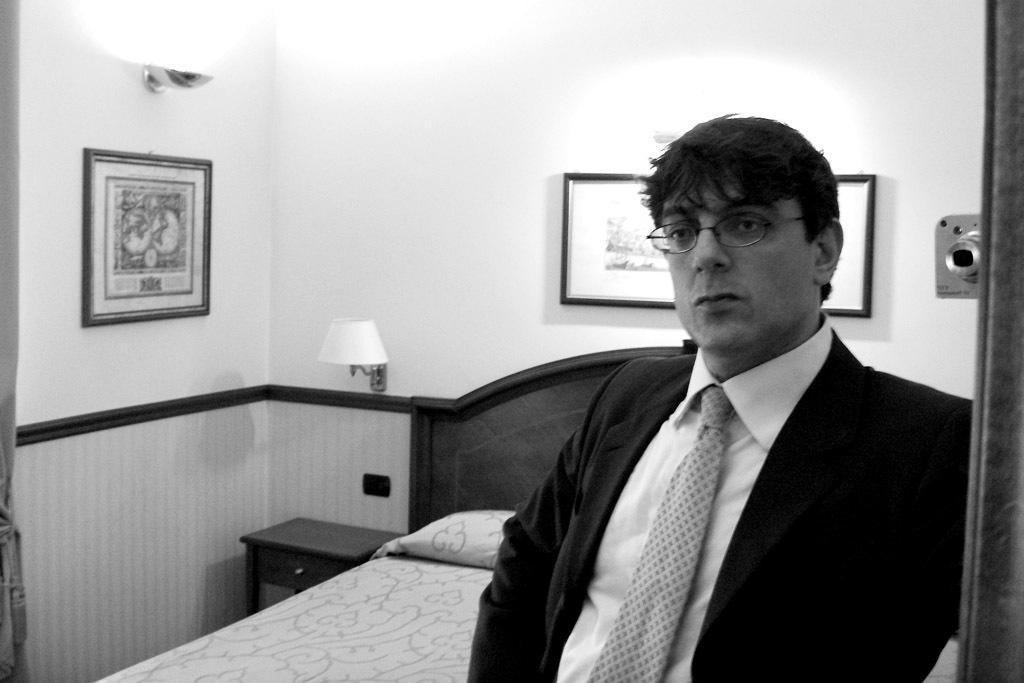What is the person in the image doing? The person is standing. What is the person wearing around their neck? The person is wearing a tie. What color is the suit the person is wearing? The person is wearing a black color suit. What accessory is the person wearing on their face? The person is wearing glasses. What can be seen behind the person? There is a wall behind the person with frames on it. What device is visible in the image? There is a camera visible. What furniture can be seen in the background? There is a bed, a lamp, and a table in the background. What type of whip is the person using to solve arithmetic problems in the image? There is no whip or arithmetic problems present in the image. 